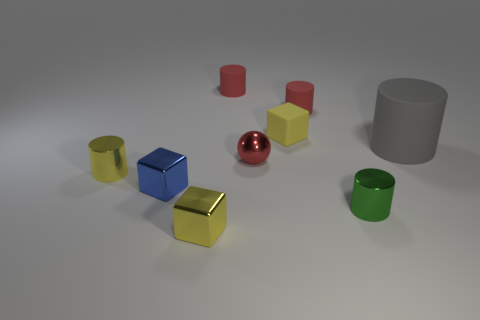Subtract 1 cylinders. How many cylinders are left? 4 Subtract all large gray cylinders. How many cylinders are left? 4 Subtract all green cylinders. How many cylinders are left? 4 Subtract all blue cylinders. Subtract all red cubes. How many cylinders are left? 5 Subtract all cubes. How many objects are left? 6 Subtract 0 brown cylinders. How many objects are left? 9 Subtract all small shiny objects. Subtract all large blue matte spheres. How many objects are left? 4 Add 4 tiny yellow cylinders. How many tiny yellow cylinders are left? 5 Add 7 small blue things. How many small blue things exist? 8 